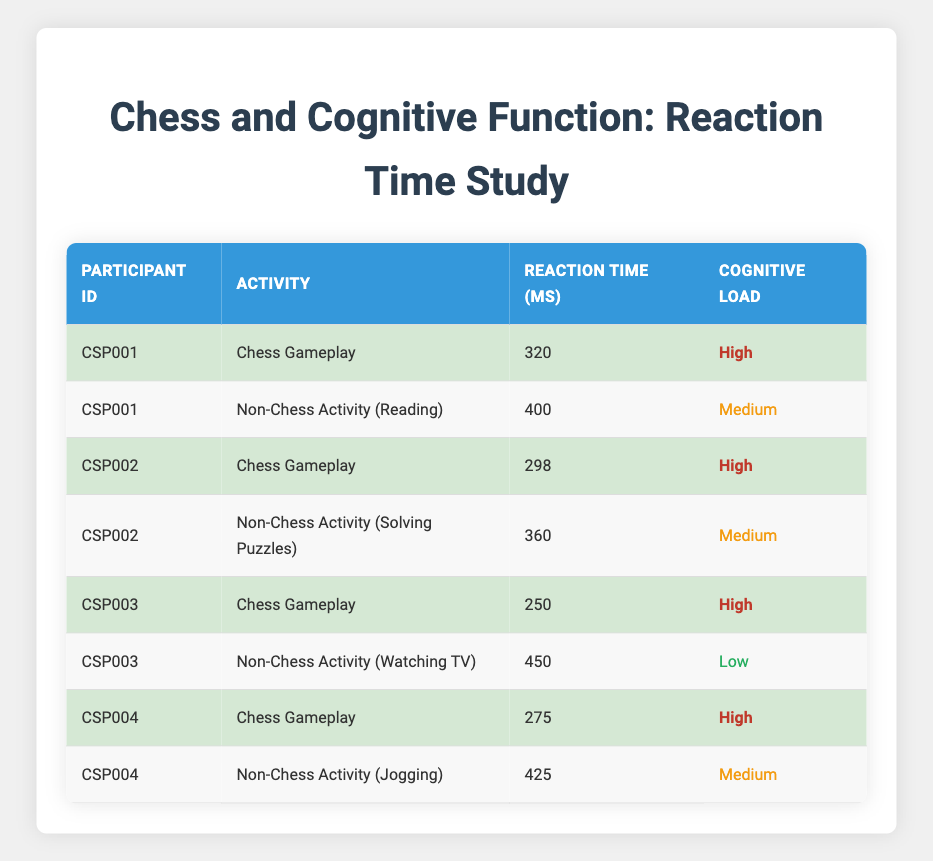What is the reaction time for CSP002 during Chess Gameplay? The table lists the reaction time for participant CSP002 under the activity "Chess Gameplay," which shows a value of 298 ms.
Answer: 298 ms What was the cognitive load for CSP003 during the Non-Chess Activity (Watching TV)? Referring to the table, CSP003's Non-Chess Activity is "Watching TV," and the cognitive load specified is "Low."
Answer: Low What is the difference in reaction time between CSP001's Chess Gameplay and Non-Chess Activity (Reading)? To find the difference, subtract the reaction time during Non-Chess Activity (400 ms) from the reaction time during Chess Gameplay (320 ms): 400 ms - 320 ms = 80 ms.
Answer: 80 ms Did any participant have a faster reaction time during Chess Gameplay compared to their Non-Chess Activity? By examining the data, CSP002 and CSP003 both recorded lower reaction times during Chess Gameplay (298 ms and 250 ms respectively) compared to their Non-Chess Activities (360 ms and 450 ms), confirming yes.
Answer: Yes What is the average reaction time for all Chess Gameplay activities? The reaction times for Chess Gameplay are 320 ms, 298 ms, 250 ms, and 275 ms. The average is calculated by summing these values (320 + 298 + 250 + 275 = 1143) and dividing by the number of participants (4): 1143 / 4 = 285.75 ms.
Answer: 285.75 ms What is the highest reaction time recorded in Non-Chess Activities? Looking at the Non-Chess Activities, the recorded reaction times are 400 ms, 360 ms, 450 ms, and 425 ms. The highest value among these is 450 ms.
Answer: 450 ms Is there any participant who had a reaction time greater than 400 ms in a Non-Chess Activity? Evaluating the Non-Chess Activities, CSP003 (450 ms) and CSP004 (425 ms) both had reaction times greater than 400 ms. Therefore, the answer is yes.
Answer: Yes What was CSP004's reaction time during the Non-Chess Activity (Jogging)? The table shows that CSP004's reaction time for the Non-Chess Activity (Jogging) is 425 ms.
Answer: 425 ms 